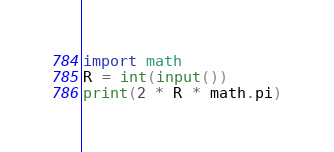Convert code to text. <code><loc_0><loc_0><loc_500><loc_500><_Python_>import math
R = int(input())
print(2 * R * math.pi)</code> 